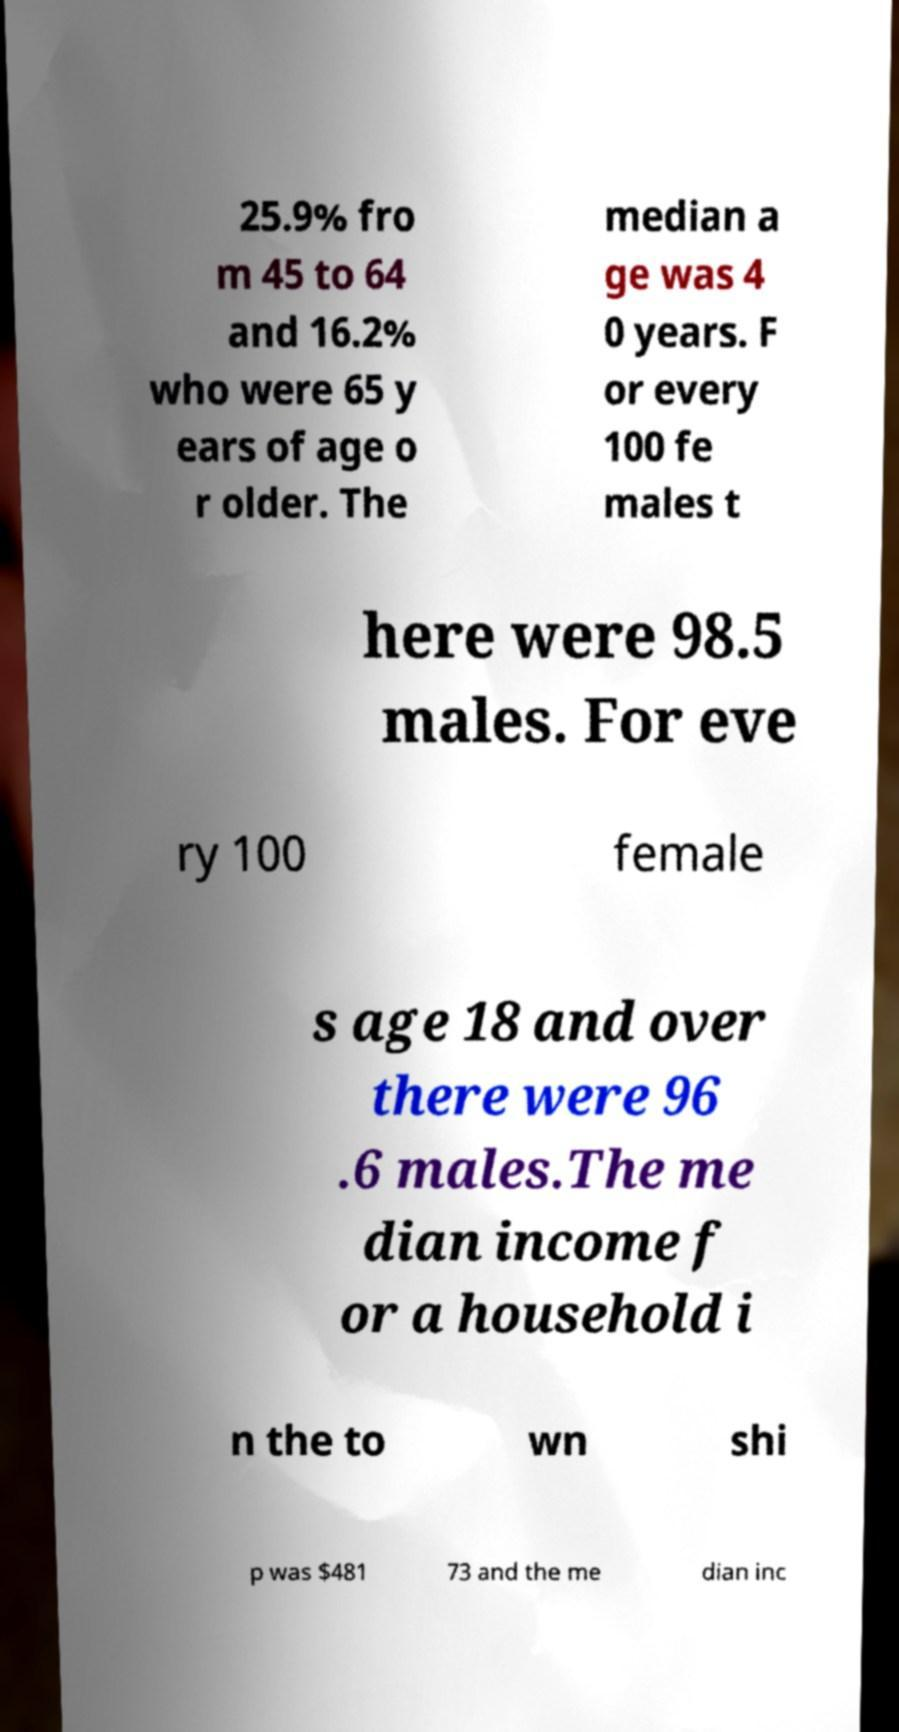Can you accurately transcribe the text from the provided image for me? 25.9% fro m 45 to 64 and 16.2% who were 65 y ears of age o r older. The median a ge was 4 0 years. F or every 100 fe males t here were 98.5 males. For eve ry 100 female s age 18 and over there were 96 .6 males.The me dian income f or a household i n the to wn shi p was $481 73 and the me dian inc 